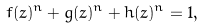<formula> <loc_0><loc_0><loc_500><loc_500>f ( z ) ^ { n } + g ( z ) ^ { n } + h ( z ) ^ { n } = 1 ,</formula> 